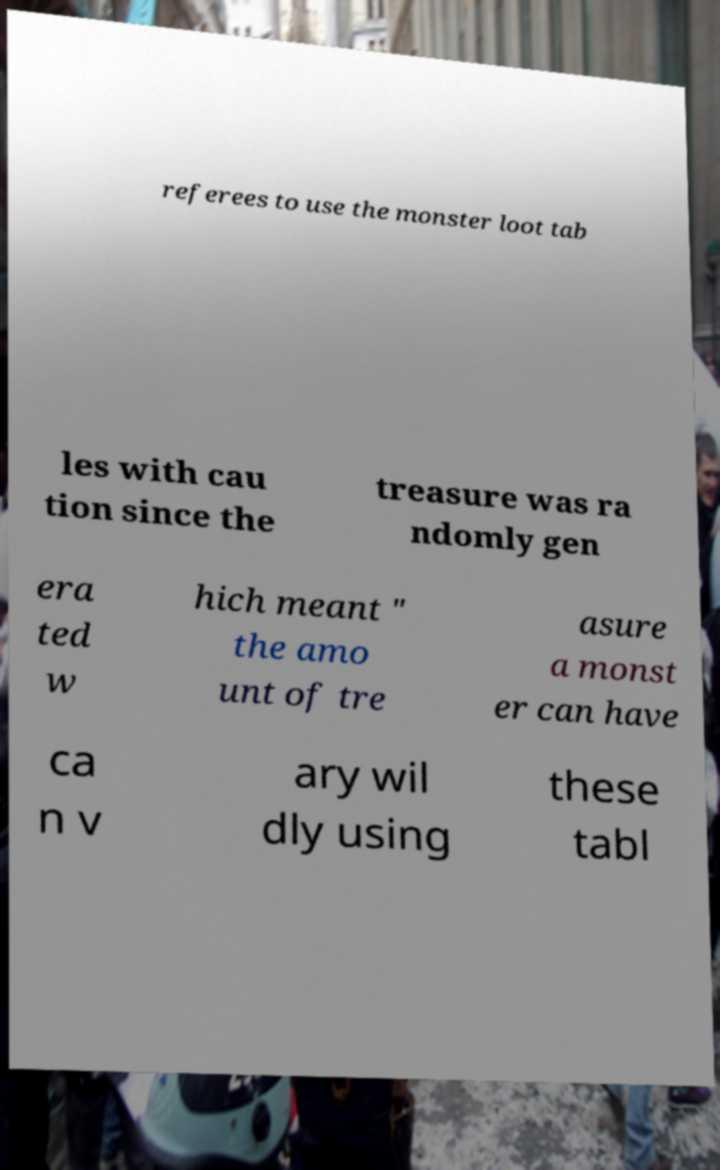I need the written content from this picture converted into text. Can you do that? referees to use the monster loot tab les with cau tion since the treasure was ra ndomly gen era ted w hich meant " the amo unt of tre asure a monst er can have ca n v ary wil dly using these tabl 